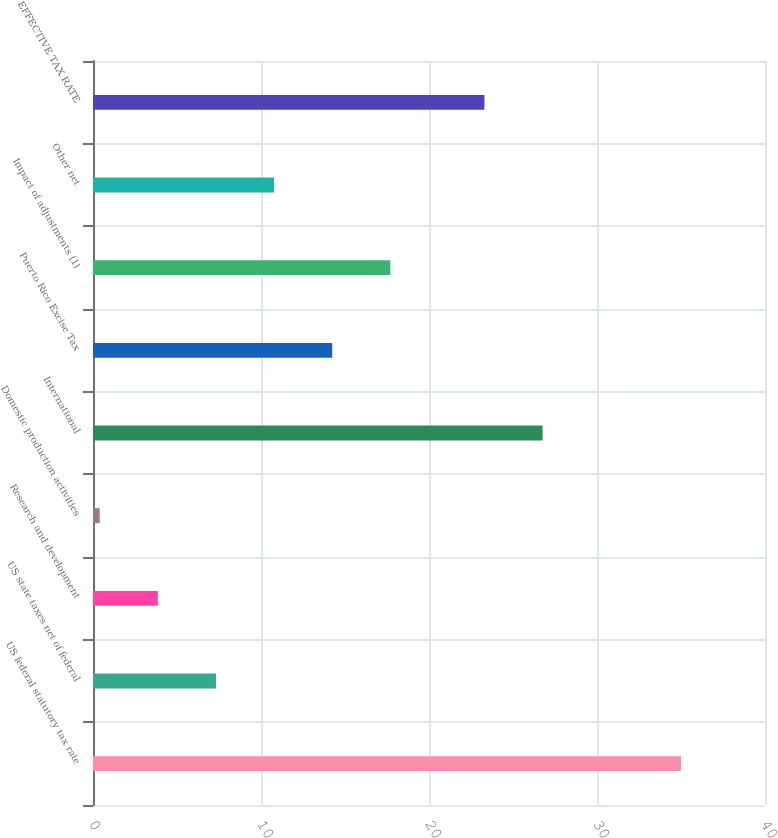<chart> <loc_0><loc_0><loc_500><loc_500><bar_chart><fcel>US federal statutory tax rate<fcel>US state taxes net of federal<fcel>Research and development<fcel>Domestic production activities<fcel>International<fcel>Puerto Rico Excise Tax<fcel>Impact of adjustments (1)<fcel>Other net<fcel>EFFECTIVE TAX RATE<nl><fcel>35<fcel>7.32<fcel>3.86<fcel>0.4<fcel>26.76<fcel>14.24<fcel>17.7<fcel>10.78<fcel>23.3<nl></chart> 